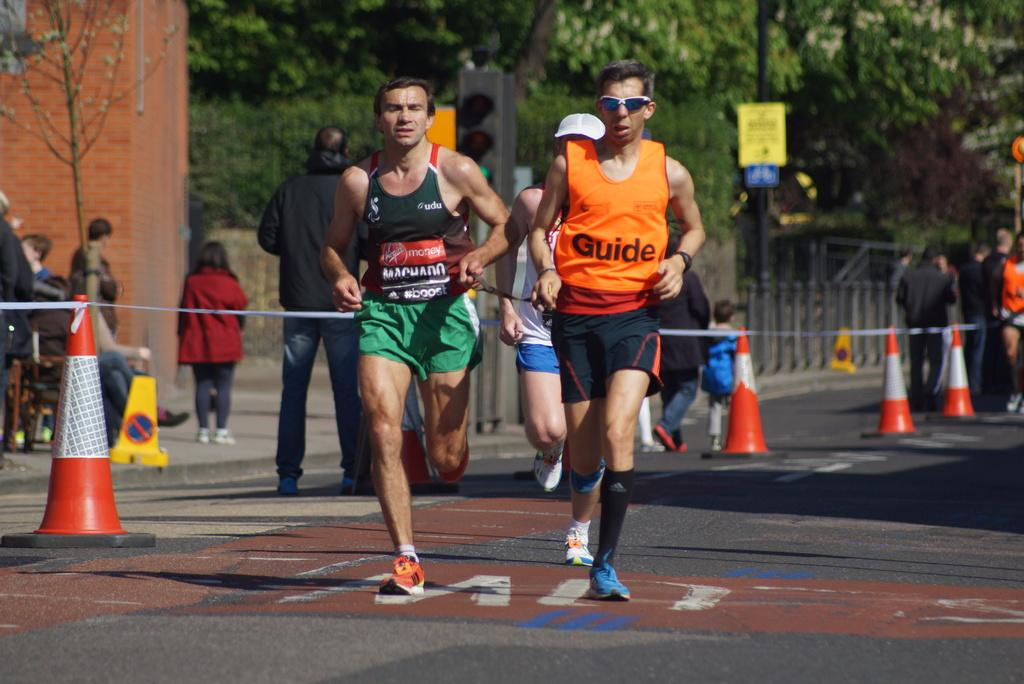<image>
Relay a brief, clear account of the picture shown. a person running in orange with the word guide on their shirt 